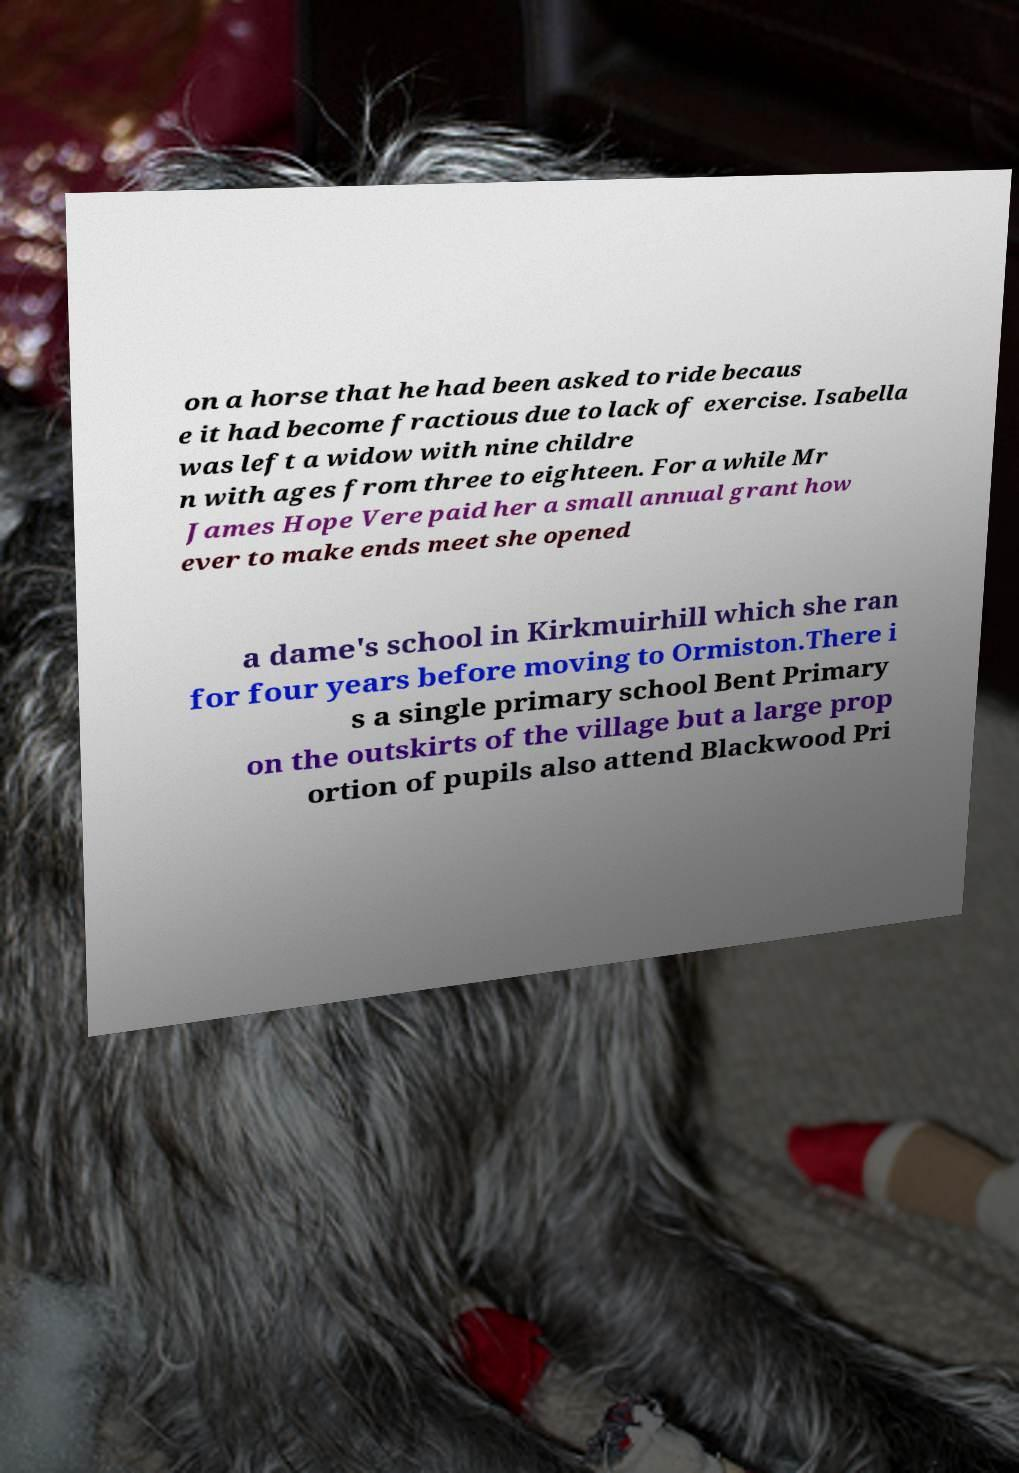What messages or text are displayed in this image? I need them in a readable, typed format. on a horse that he had been asked to ride becaus e it had become fractious due to lack of exercise. Isabella was left a widow with nine childre n with ages from three to eighteen. For a while Mr James Hope Vere paid her a small annual grant how ever to make ends meet she opened a dame's school in Kirkmuirhill which she ran for four years before moving to Ormiston.There i s a single primary school Bent Primary on the outskirts of the village but a large prop ortion of pupils also attend Blackwood Pri 